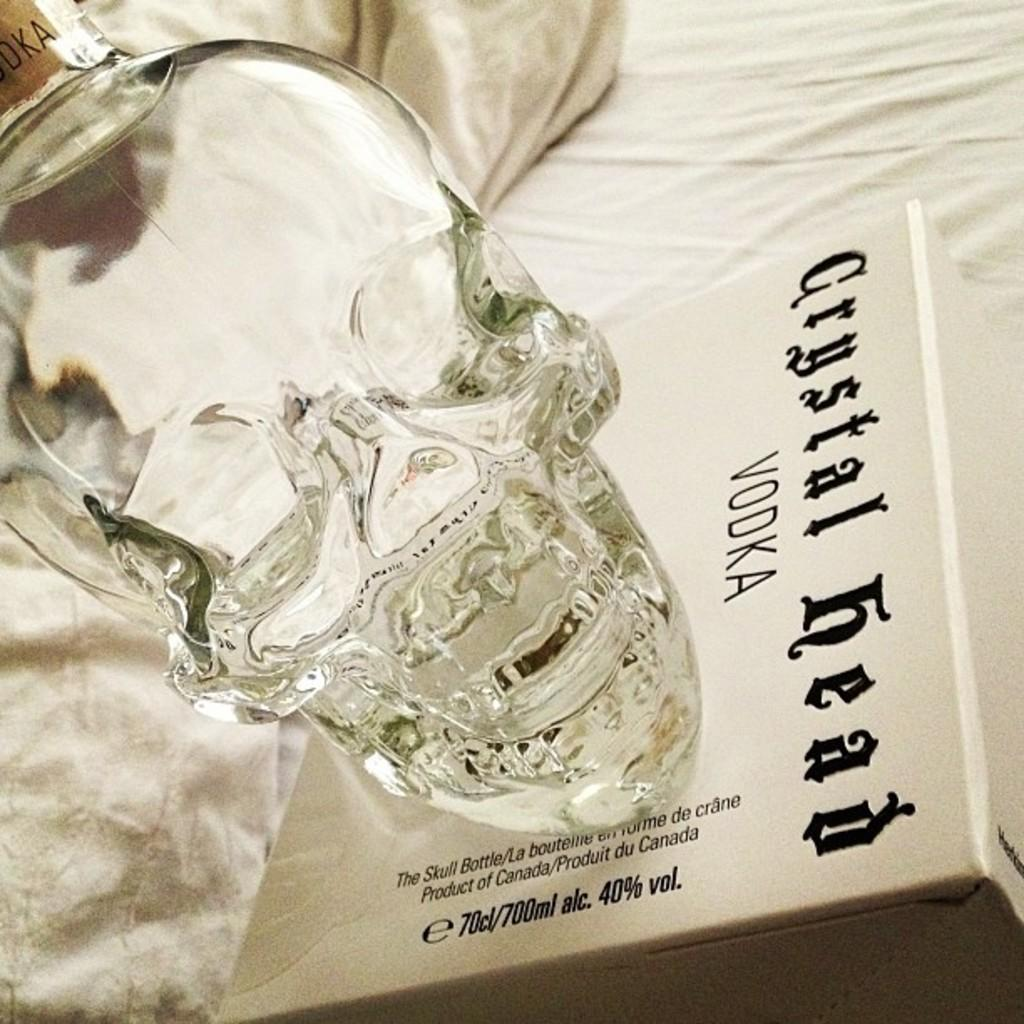<image>
Provide a brief description of the given image. A bottle of vodka Crystal Head brand, and the box that it was packaged in. 